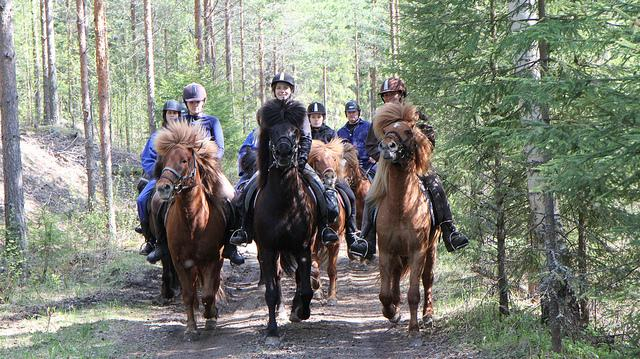What is unusually long here? manes 